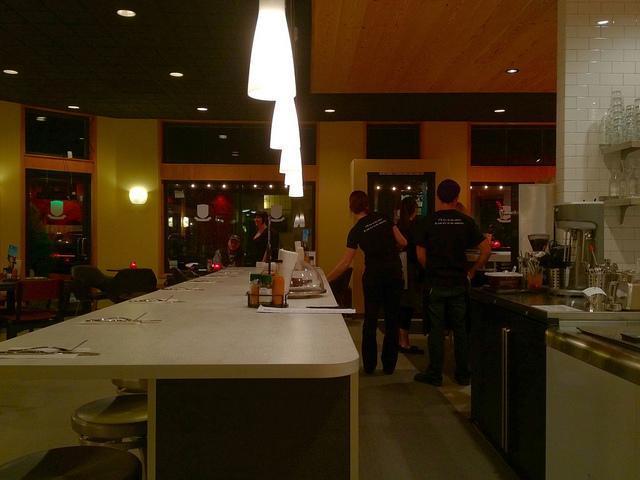What type of counter is shown?
Indicate the correct response and explain using: 'Answer: answer
Rationale: rationale.'
Options: Check-out, kitchen, bathroom, restaurant. Answer: restaurant.
Rationale: It is a restaurant because it has tables, a counter, a kitchen and waiters 